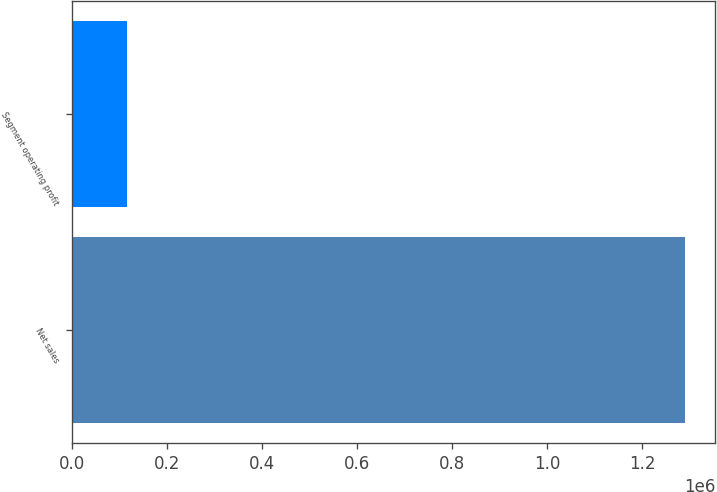<chart> <loc_0><loc_0><loc_500><loc_500><bar_chart><fcel>Net sales<fcel>Segment operating profit<nl><fcel>1.28931e+06<fcel>116457<nl></chart> 